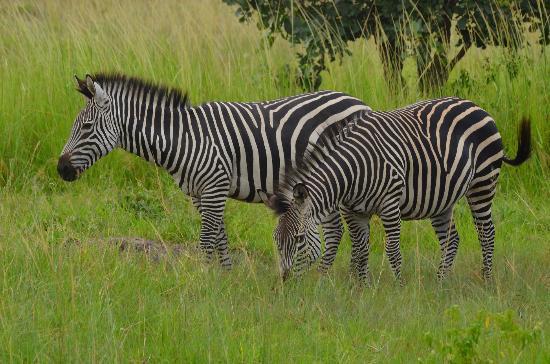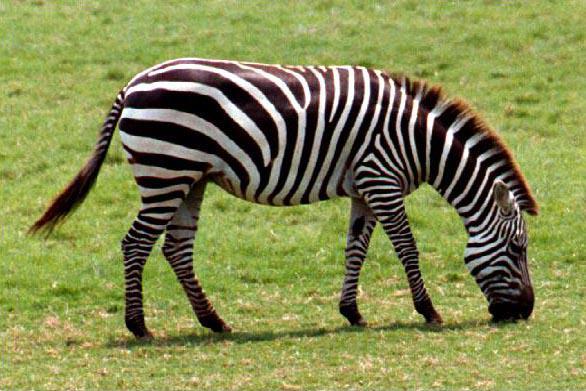The first image is the image on the left, the second image is the image on the right. Analyze the images presented: Is the assertion "No more than one zebra has its head down in the image on the right." valid? Answer yes or no. Yes. The first image is the image on the left, the second image is the image on the right. Assess this claim about the two images: "In the foreground of the lefthand image, two zebras stand with bodies turned toward each other and faces turned to the camera.". Correct or not? Answer yes or no. No. 